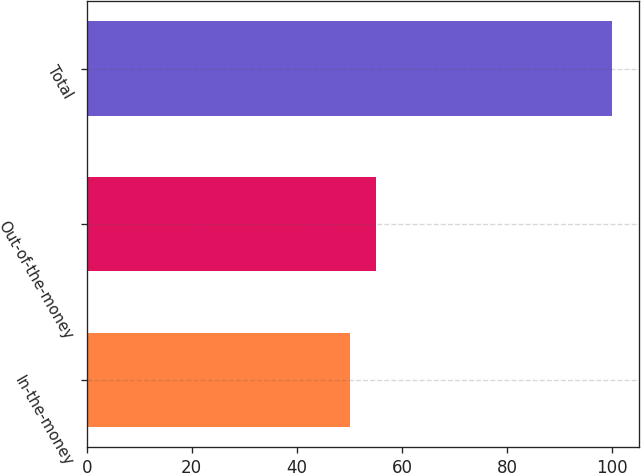<chart> <loc_0><loc_0><loc_500><loc_500><bar_chart><fcel>In-the-money<fcel>Out-of-the-money<fcel>Total<nl><fcel>50<fcel>55<fcel>100<nl></chart> 